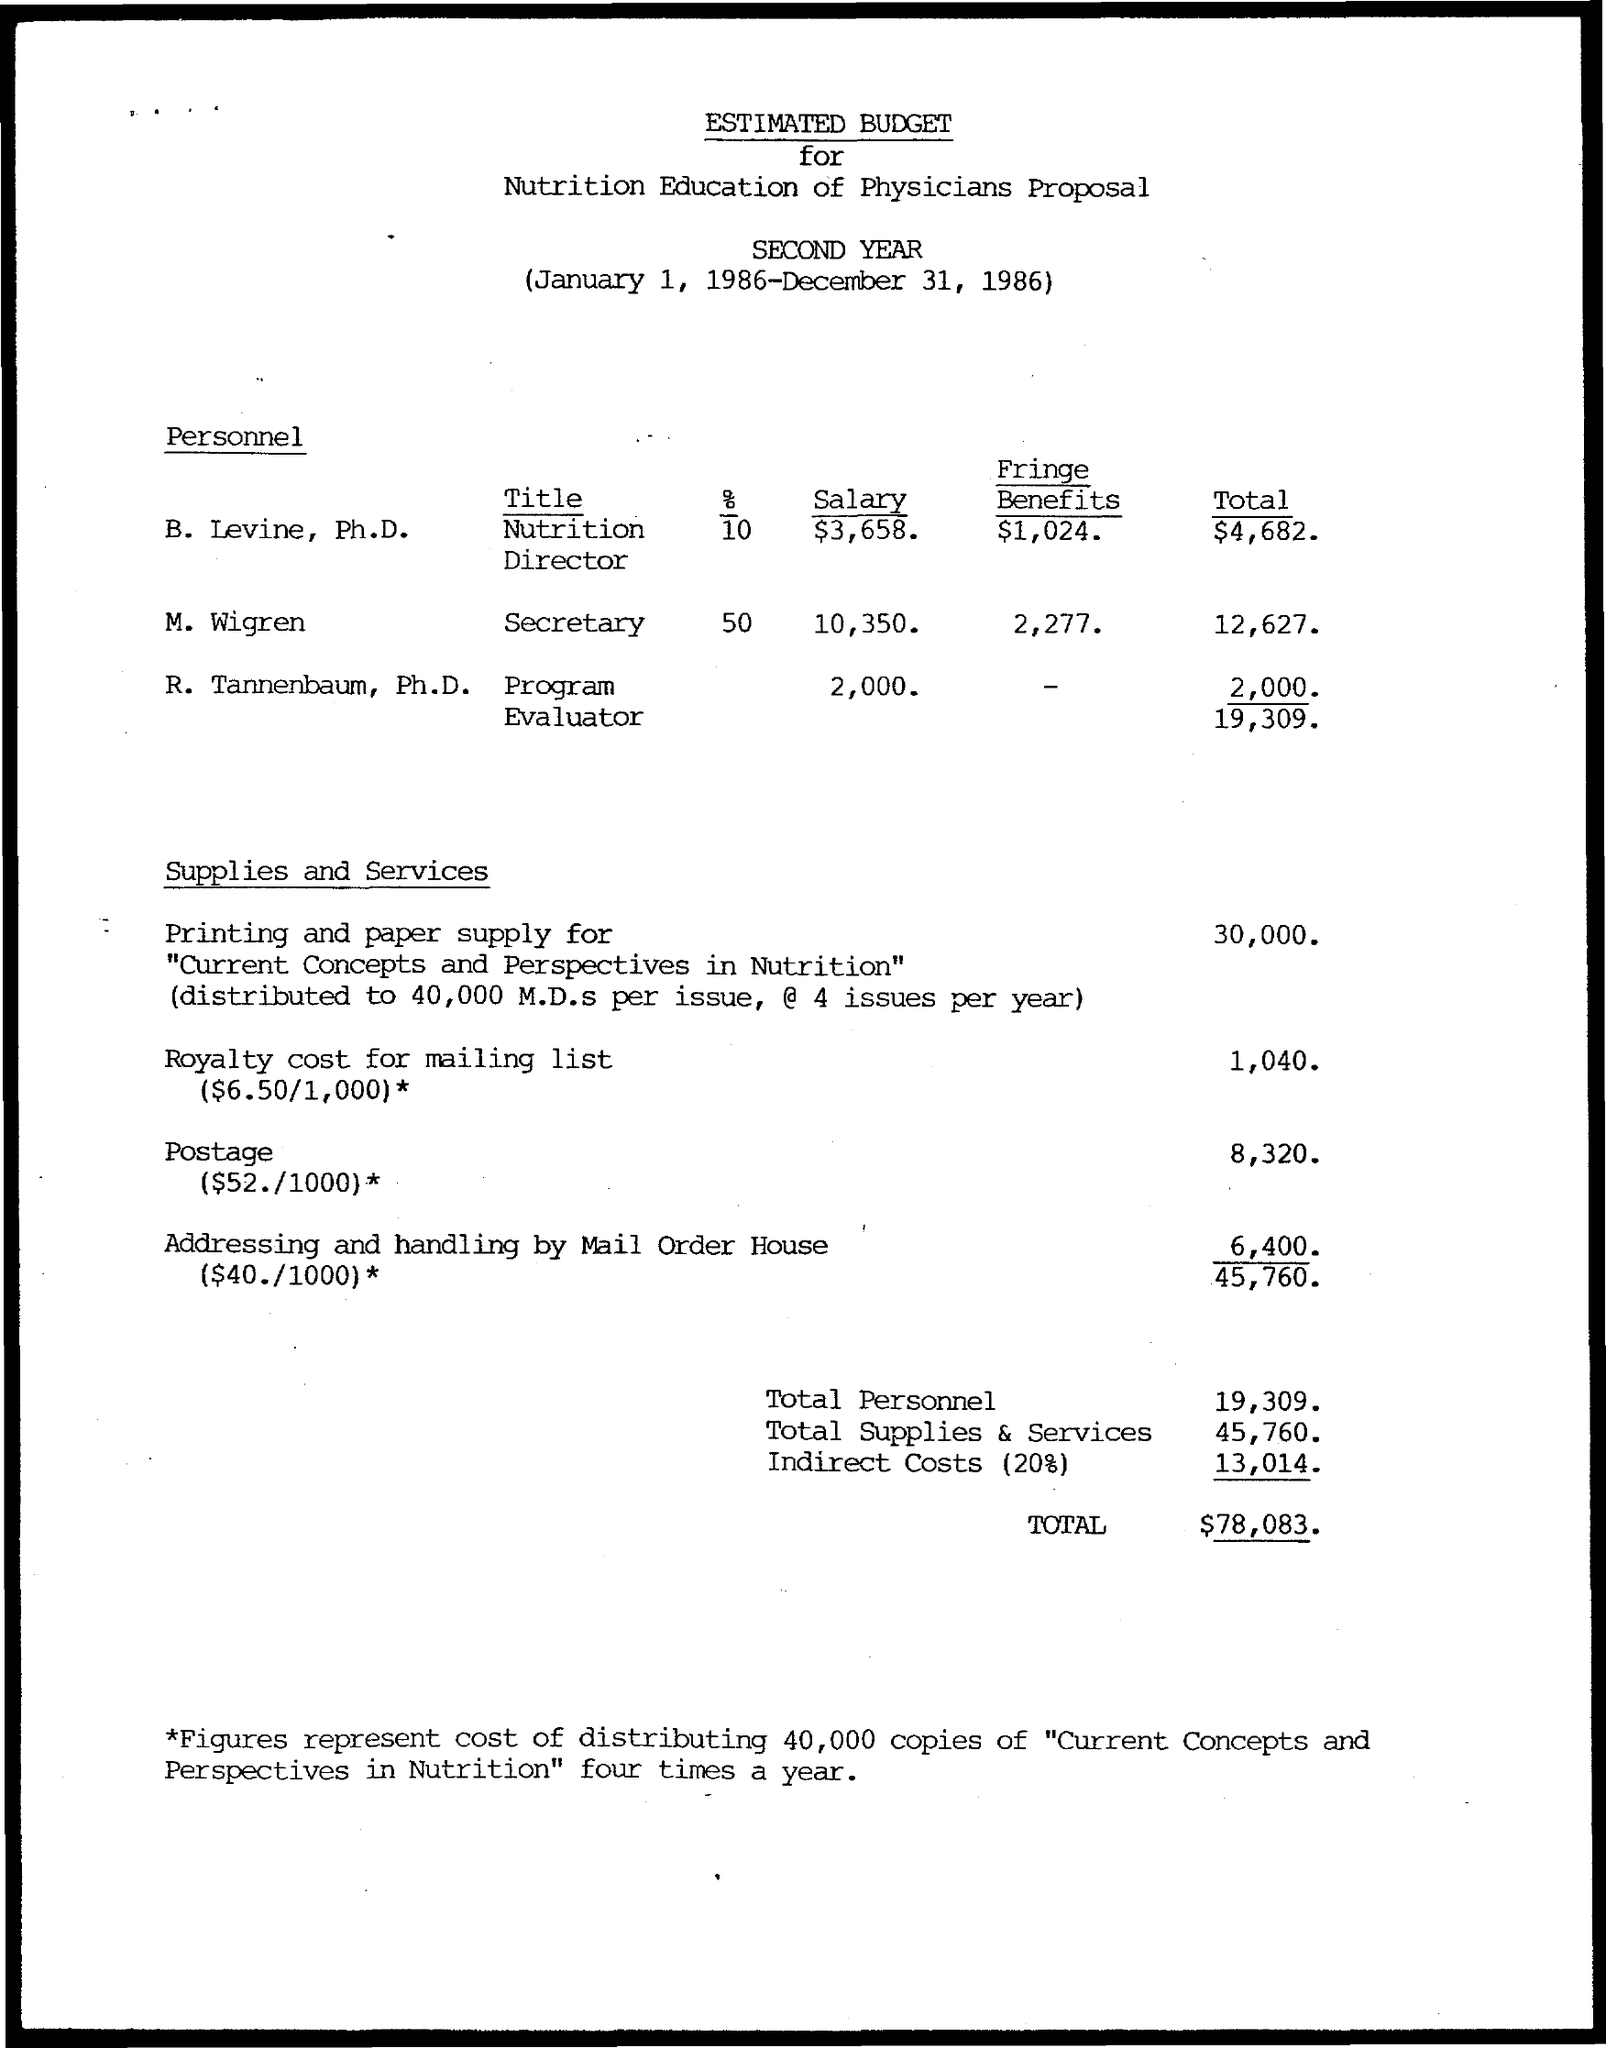Draw attention to some important aspects in this diagram. The salary for M. Wigren is 10,350... The total for Levine, Ph.D. is $4,682. The total cost for Tannenbaum, Ph.D. is 2,000... The title for Levine, Ph.D. is "Nutrition Director. Tannenbaum, Ph.D., is a program evaluator. 